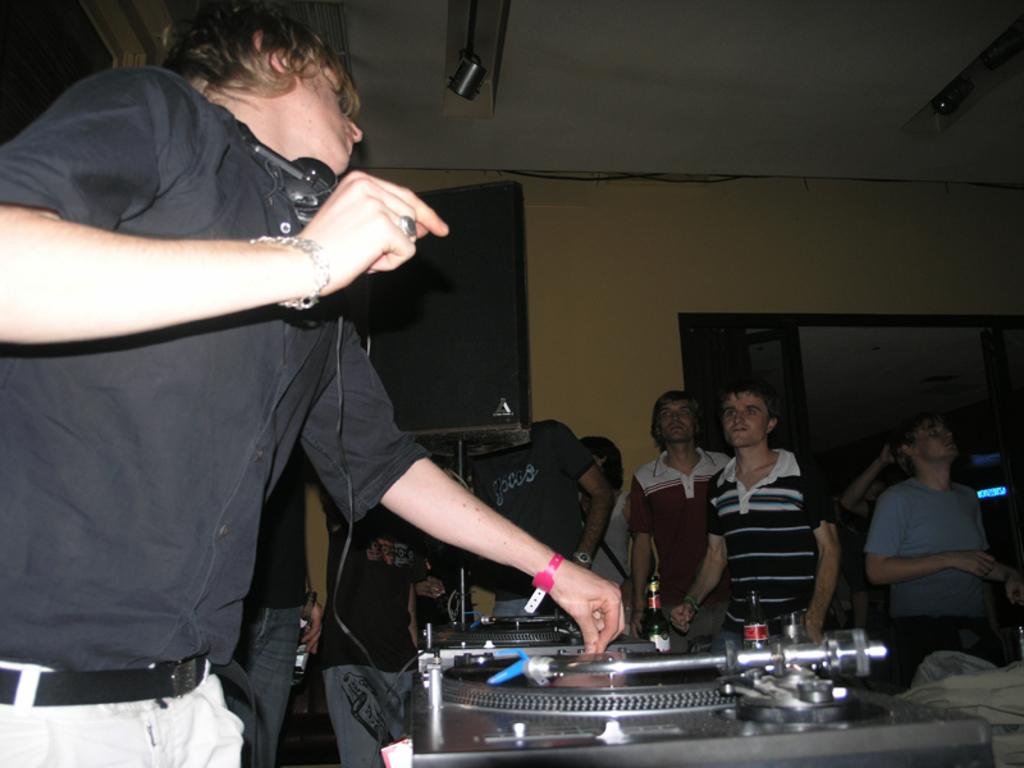What is happening with the group of people in the image? The group of people is on the floor. What else can be seen in the image besides the people? There are equipment, a wall, a speaker stand, and a door visible in the background. What is the setting of the image? The image may have been taken in a hall, as suggested by the presence of a rooftop visible in the background. Is there a slope in the image? No, there is no slope present in the image. Is it raining in the image? No, there is no indication of rain in the image. 